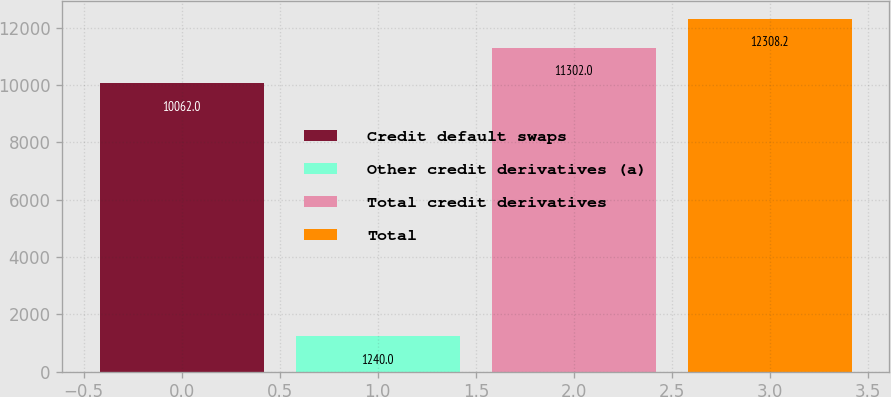Convert chart to OTSL. <chart><loc_0><loc_0><loc_500><loc_500><bar_chart><fcel>Credit default swaps<fcel>Other credit derivatives (a)<fcel>Total credit derivatives<fcel>Total<nl><fcel>10062<fcel>1240<fcel>11302<fcel>12308.2<nl></chart> 